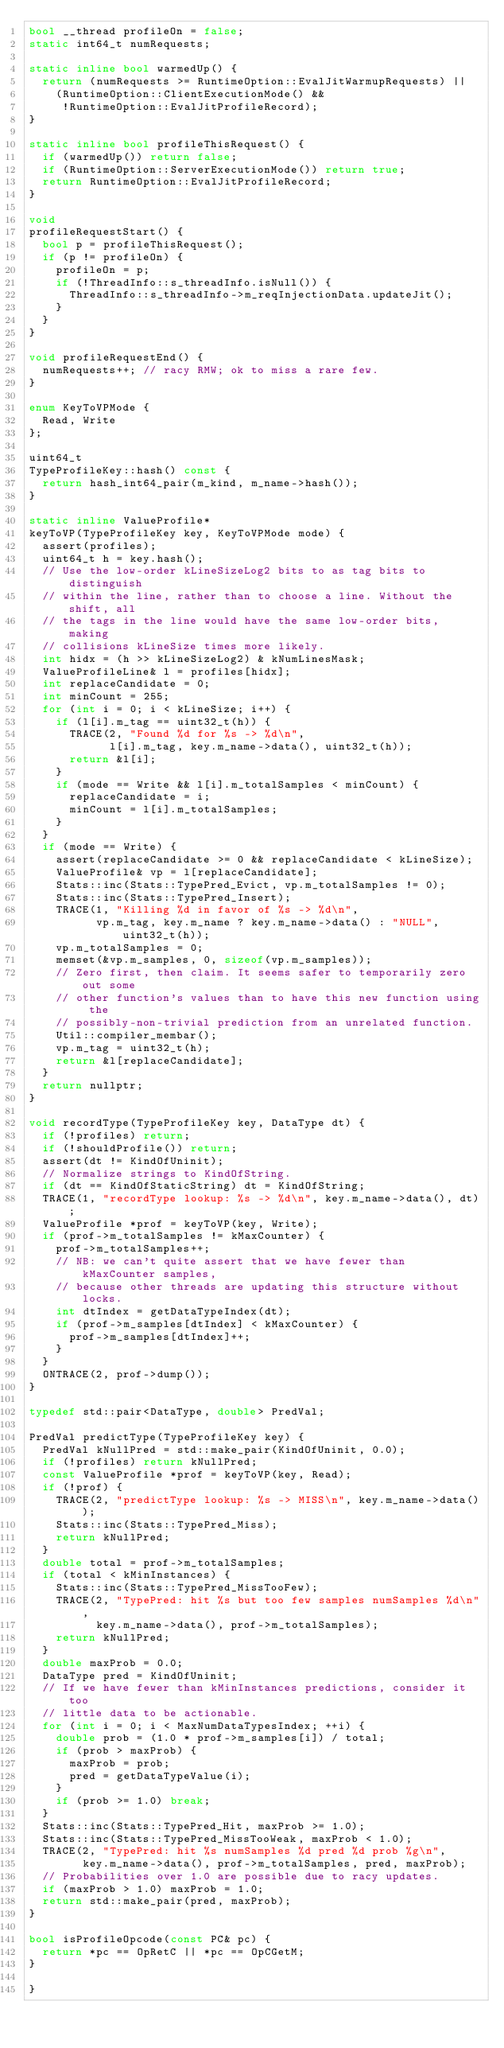<code> <loc_0><loc_0><loc_500><loc_500><_C++_>bool __thread profileOn = false;
static int64_t numRequests;

static inline bool warmedUp() {
  return (numRequests >= RuntimeOption::EvalJitWarmupRequests) ||
    (RuntimeOption::ClientExecutionMode() &&
     !RuntimeOption::EvalJitProfileRecord);
}

static inline bool profileThisRequest() {
  if (warmedUp()) return false;
  if (RuntimeOption::ServerExecutionMode()) return true;
  return RuntimeOption::EvalJitProfileRecord;
}

void
profileRequestStart() {
  bool p = profileThisRequest();
  if (p != profileOn) {
    profileOn = p;
    if (!ThreadInfo::s_threadInfo.isNull()) {
      ThreadInfo::s_threadInfo->m_reqInjectionData.updateJit();
    }
  }
}

void profileRequestEnd() {
  numRequests++; // racy RMW; ok to miss a rare few.
}

enum KeyToVPMode {
  Read, Write
};

uint64_t
TypeProfileKey::hash() const {
  return hash_int64_pair(m_kind, m_name->hash());
}

static inline ValueProfile*
keyToVP(TypeProfileKey key, KeyToVPMode mode) {
  assert(profiles);
  uint64_t h = key.hash();
  // Use the low-order kLineSizeLog2 bits to as tag bits to distinguish
  // within the line, rather than to choose a line. Without the shift, all
  // the tags in the line would have the same low-order bits, making
  // collisions kLineSize times more likely.
  int hidx = (h >> kLineSizeLog2) & kNumLinesMask;
  ValueProfileLine& l = profiles[hidx];
  int replaceCandidate = 0;
  int minCount = 255;
  for (int i = 0; i < kLineSize; i++) {
    if (l[i].m_tag == uint32_t(h)) {
      TRACE(2, "Found %d for %s -> %d\n",
            l[i].m_tag, key.m_name->data(), uint32_t(h));
      return &l[i];
    }
    if (mode == Write && l[i].m_totalSamples < minCount) {
      replaceCandidate = i;
      minCount = l[i].m_totalSamples;
    }
  }
  if (mode == Write) {
    assert(replaceCandidate >= 0 && replaceCandidate < kLineSize);
    ValueProfile& vp = l[replaceCandidate];
    Stats::inc(Stats::TypePred_Evict, vp.m_totalSamples != 0);
    Stats::inc(Stats::TypePred_Insert);
    TRACE(1, "Killing %d in favor of %s -> %d\n",
          vp.m_tag, key.m_name ? key.m_name->data() : "NULL", uint32_t(h));
    vp.m_totalSamples = 0;
    memset(&vp.m_samples, 0, sizeof(vp.m_samples));
    // Zero first, then claim. It seems safer to temporarily zero out some
    // other function's values than to have this new function using the
    // possibly-non-trivial prediction from an unrelated function.
    Util::compiler_membar();
    vp.m_tag = uint32_t(h);
    return &l[replaceCandidate];
  }
  return nullptr;
}

void recordType(TypeProfileKey key, DataType dt) {
  if (!profiles) return;
  if (!shouldProfile()) return;
  assert(dt != KindOfUninit);
  // Normalize strings to KindOfString.
  if (dt == KindOfStaticString) dt = KindOfString;
  TRACE(1, "recordType lookup: %s -> %d\n", key.m_name->data(), dt);
  ValueProfile *prof = keyToVP(key, Write);
  if (prof->m_totalSamples != kMaxCounter) {
    prof->m_totalSamples++;
    // NB: we can't quite assert that we have fewer than kMaxCounter samples,
    // because other threads are updating this structure without locks.
    int dtIndex = getDataTypeIndex(dt);
    if (prof->m_samples[dtIndex] < kMaxCounter) {
      prof->m_samples[dtIndex]++;
    }
  }
  ONTRACE(2, prof->dump());
}

typedef std::pair<DataType, double> PredVal;

PredVal predictType(TypeProfileKey key) {
  PredVal kNullPred = std::make_pair(KindOfUninit, 0.0);
  if (!profiles) return kNullPred;
  const ValueProfile *prof = keyToVP(key, Read);
  if (!prof) {
    TRACE(2, "predictType lookup: %s -> MISS\n", key.m_name->data());
    Stats::inc(Stats::TypePred_Miss);
    return kNullPred;
  }
  double total = prof->m_totalSamples;
  if (total < kMinInstances) {
    Stats::inc(Stats::TypePred_MissTooFew);
    TRACE(2, "TypePred: hit %s but too few samples numSamples %d\n",
          key.m_name->data(), prof->m_totalSamples);
    return kNullPred;
  }
  double maxProb = 0.0;
  DataType pred = KindOfUninit;
  // If we have fewer than kMinInstances predictions, consider it too
  // little data to be actionable.
  for (int i = 0; i < MaxNumDataTypesIndex; ++i) {
    double prob = (1.0 * prof->m_samples[i]) / total;
    if (prob > maxProb) {
      maxProb = prob;
      pred = getDataTypeValue(i);
    }
    if (prob >= 1.0) break;
  }
  Stats::inc(Stats::TypePred_Hit, maxProb >= 1.0);
  Stats::inc(Stats::TypePred_MissTooWeak, maxProb < 1.0);
  TRACE(2, "TypePred: hit %s numSamples %d pred %d prob %g\n",
        key.m_name->data(), prof->m_totalSamples, pred, maxProb);
  // Probabilities over 1.0 are possible due to racy updates.
  if (maxProb > 1.0) maxProb = 1.0;
  return std::make_pair(pred, maxProb);
}

bool isProfileOpcode(const PC& pc) {
  return *pc == OpRetC || *pc == OpCGetM;
}

}
</code> 